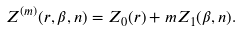<formula> <loc_0><loc_0><loc_500><loc_500>Z ^ { ( m ) } ( r , \beta , n ) = Z _ { 0 } ( r ) + m Z _ { 1 } ( \beta , n ) .</formula> 